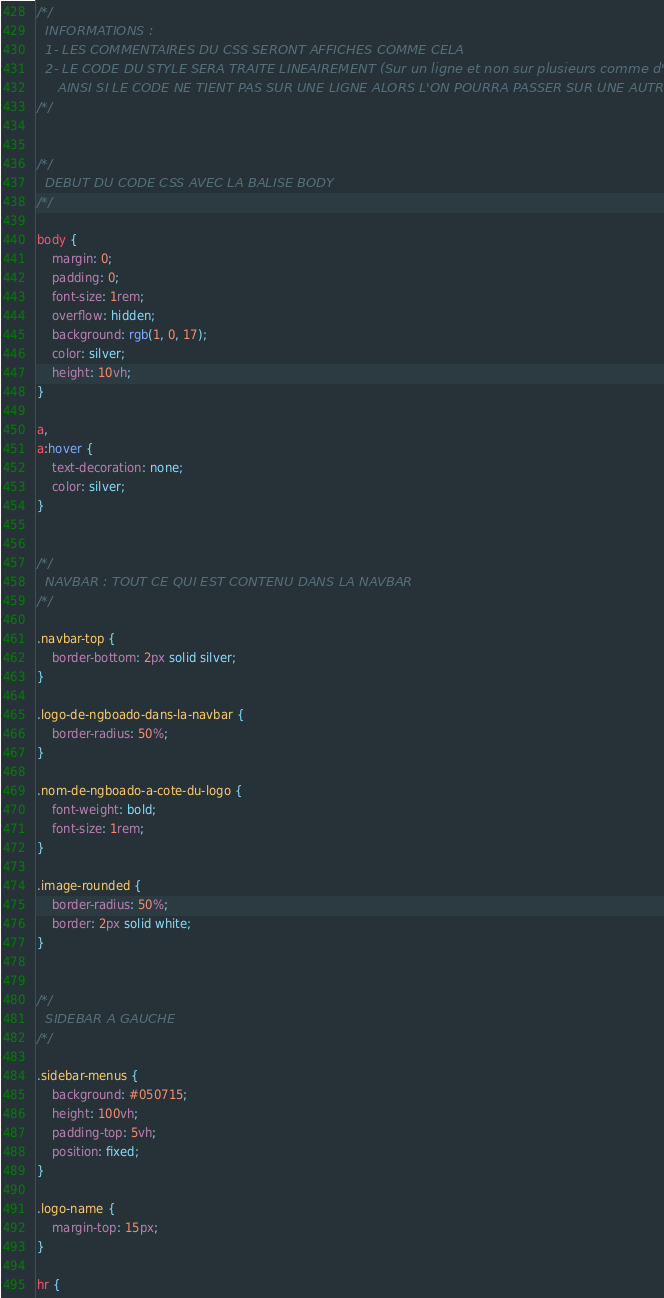Convert code to text. <code><loc_0><loc_0><loc_500><loc_500><_CSS_>/*/
  INFORMATIONS :
  1- LES COMMENTAIRES DU CSS SERONT AFFICHES COMME CELA
  2- LE CODE DU STYLE SERA TRAITE LINEAIREMENT (Sur un ligne et non sur plusieurs comme d'habitude.)
     AINSI SI LE CODE NE TIENT PAS SUR UNE LIGNE ALORS L'ON POURRA PASSER SUR UNE AUTRE LIGNE
/*/


/*/
  DEBUT DU CODE CSS AVEC LA BALISE BODY
/*/

body {
    margin: 0;
    padding: 0;
    font-size: 1rem;
    overflow: hidden;
    background: rgb(1, 0, 17);
    color: silver;
    height: 10vh;
}

a,
a:hover {
    text-decoration: none;
    color: silver;
}


/*/
  NAVBAR : TOUT CE QUI EST CONTENU DANS LA NAVBAR
/*/

.navbar-top {
    border-bottom: 2px solid silver;
}

.logo-de-ngboado-dans-la-navbar {
    border-radius: 50%;
}

.nom-de-ngboado-a-cote-du-logo {
    font-weight: bold;
    font-size: 1rem;
}

.image-rounded {
    border-radius: 50%;
    border: 2px solid white;
}


/*/
  SIDEBAR A GAUCHE
/*/

.sidebar-menus {
    background: #050715;
    height: 100vh;
    padding-top: 5vh;
    position: fixed;
}

.logo-name {
    margin-top: 15px;
}

hr {</code> 